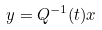<formula> <loc_0><loc_0><loc_500><loc_500>y = Q ^ { - 1 } ( t ) x</formula> 